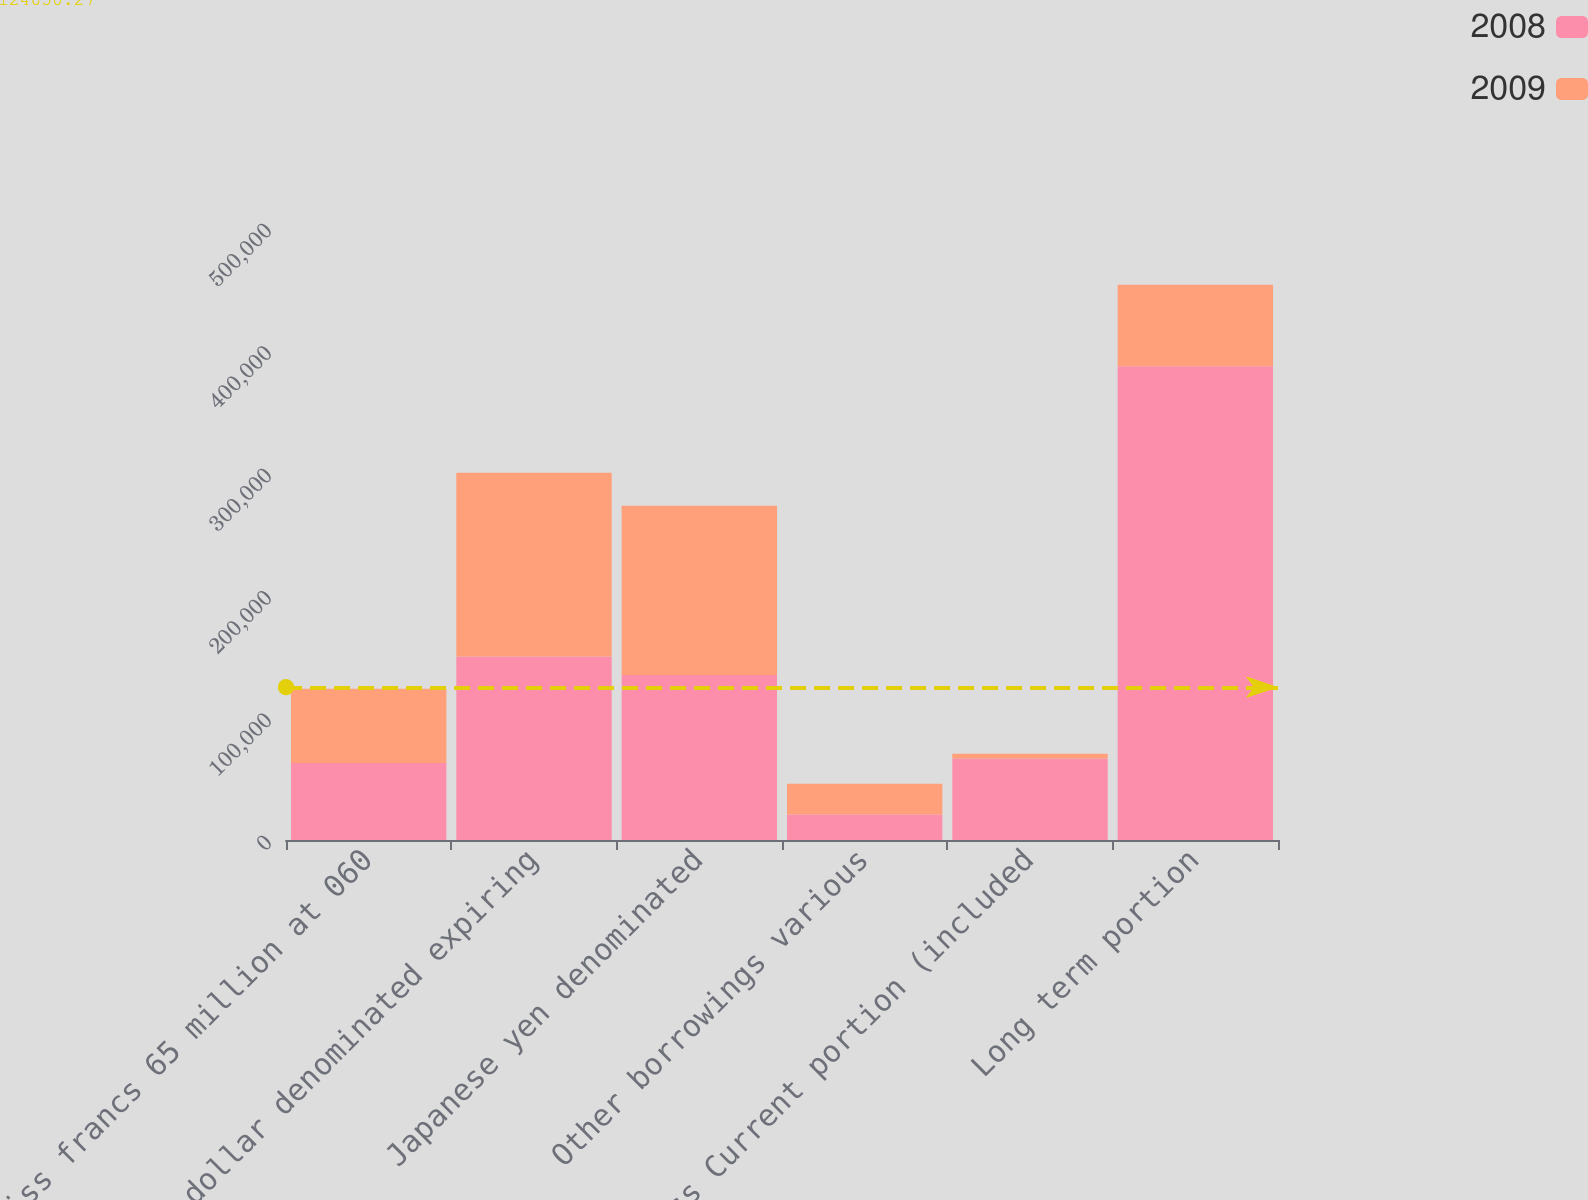Convert chart. <chart><loc_0><loc_0><loc_500><loc_500><stacked_bar_chart><ecel><fcel>Swiss francs 65 million at 060<fcel>US dollar denominated expiring<fcel>Japanese yen denominated<fcel>Other borrowings various<fcel>Less Current portion (included<fcel>Long term portion<nl><fcel>2008<fcel>62844<fcel>150000<fcel>134776<fcel>20911<fcel>66580<fcel>387151<nl><fcel>2009<fcel>60809<fcel>150000<fcel>138247<fcel>25096<fcel>3980<fcel>66580<nl></chart> 